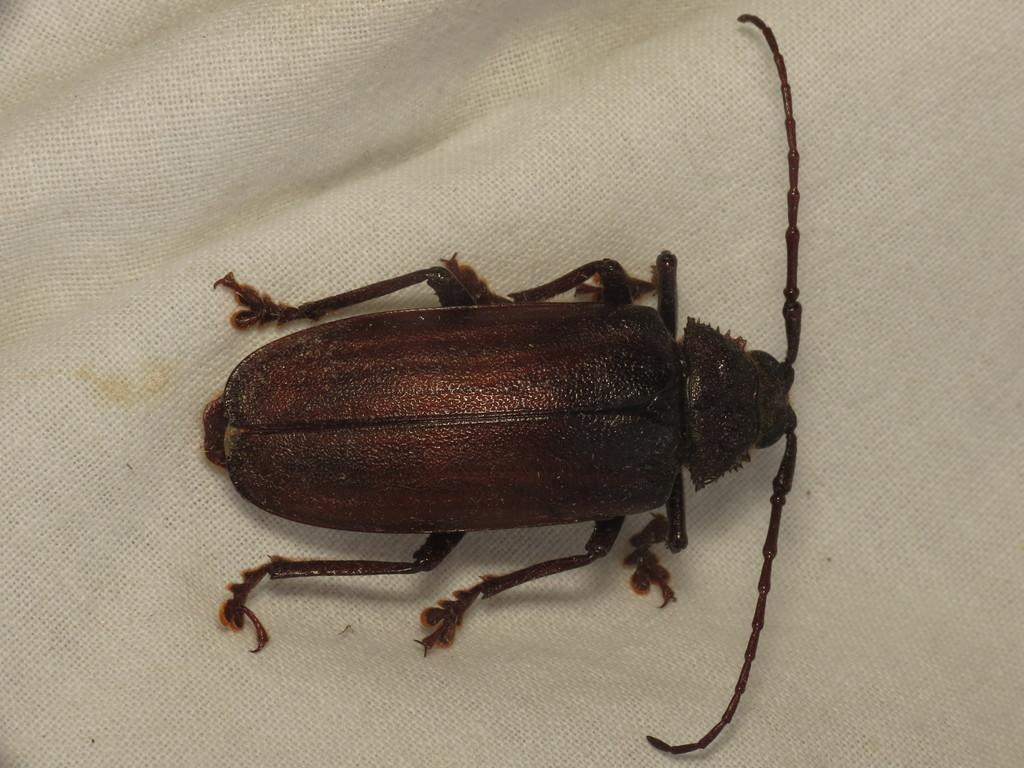How would you summarize this image in a sentence or two? In this image there is a cockroach on a white cloth. 